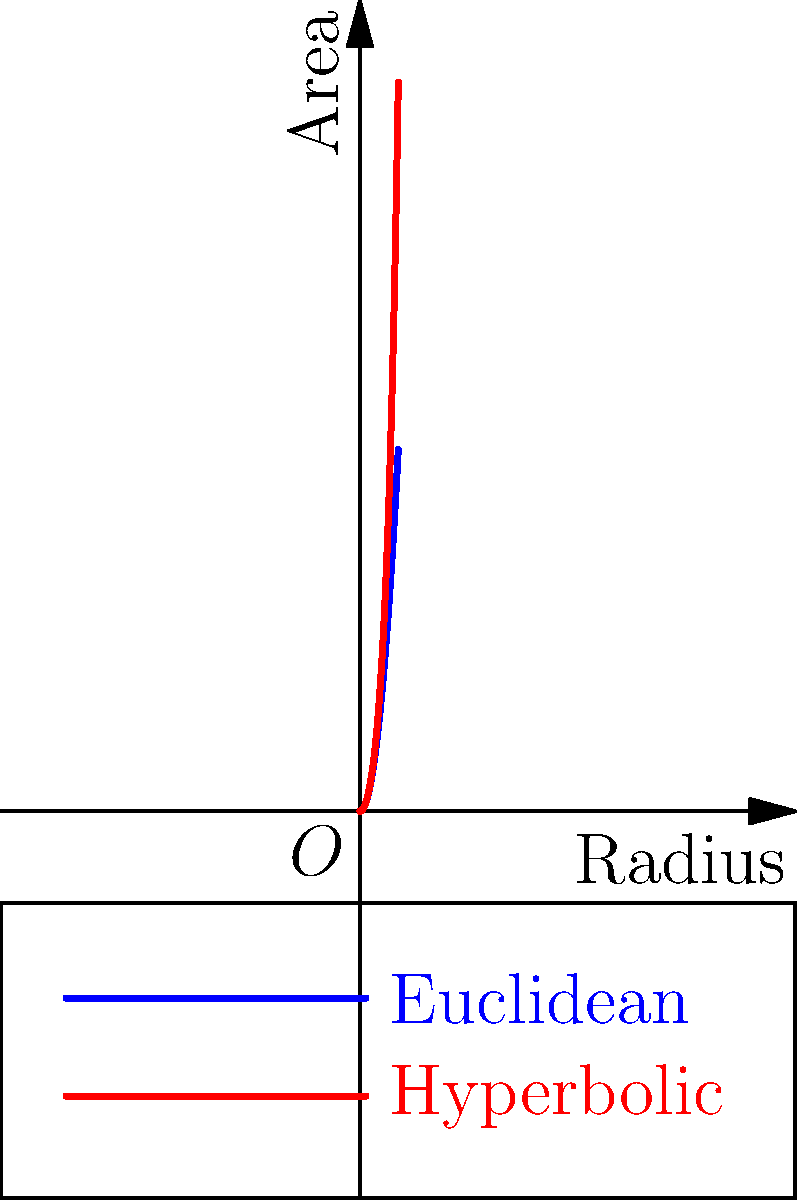In the early 1900s, non-Euclidean geometry was gaining popularity in academic circles. If you were explaining the difference between Euclidean and hyperbolic geometry to the 1920 Notre Dame football team, which of the following statements about the graph would be most accurate?
A) The blue line represents hyperbolic geometry, showing slower area growth.
B) The red line represents hyperbolic geometry, showing faster area growth.
C) Both lines represent Euclidean geometry for different types of circles.
D) The graph shows no significant difference between the two geometries. To answer this question, let's analyze the graph step-by-step:

1) The graph shows two curves: a blue one and a red one.

2) The x-axis represents the radius of a circle, while the y-axis represents its area.

3) In Euclidean geometry, the area of a circle is given by the formula $A = \pi r^2$. This results in a quadratic growth curve, which is represented by the blue line in the graph.

4) In hyperbolic geometry, the area of a circle grows much faster with respect to its radius. The formula for the area of a hyperbolic circle is $A = 4\pi \sinh^2(r/2)$, where sinh is the hyperbolic sine function.

5) The red curve in the graph shows a much steeper increase in area as the radius grows, compared to the blue curve.

6) Therefore, the red line must represent hyperbolic geometry, while the blue line represents Euclidean geometry.

7) The hyperbolic geometry (red line) shows a faster area growth compared to Euclidean geometry (blue line).

Given this analysis, the most accurate statement is option B: The red line represents hyperbolic geometry, showing faster area growth.
Answer: B 